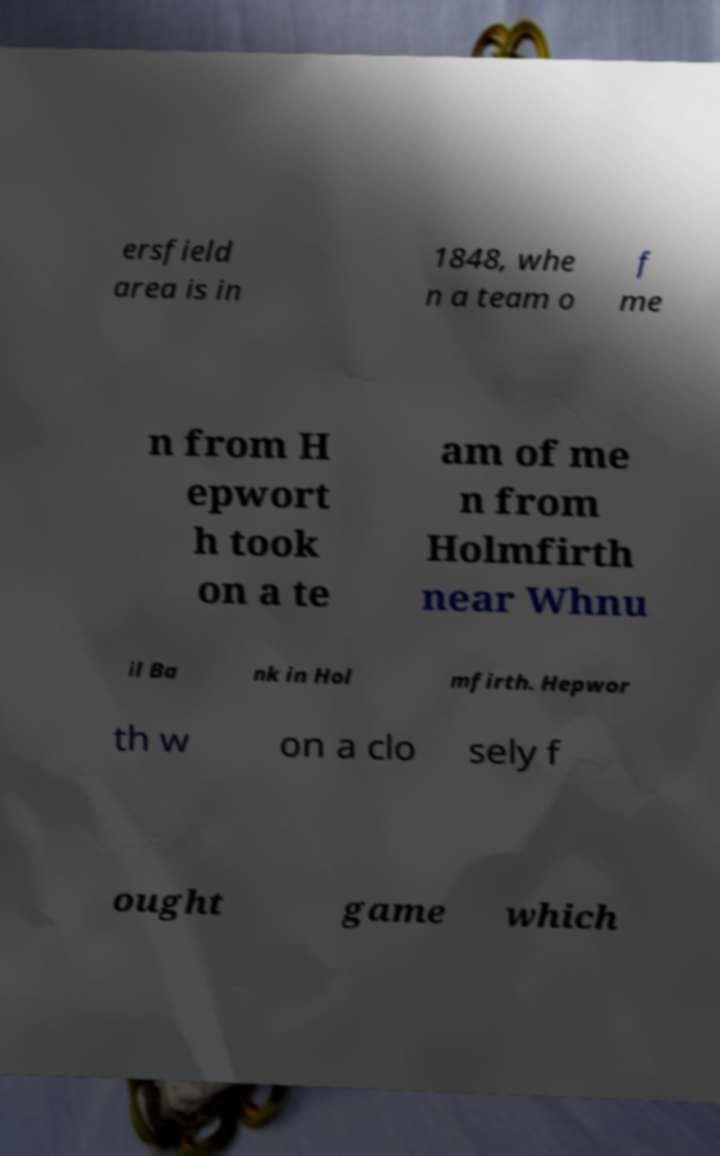What messages or text are displayed in this image? I need them in a readable, typed format. ersfield area is in 1848, whe n a team o f me n from H epwort h took on a te am of me n from Holmfirth near Whnu il Ba nk in Hol mfirth. Hepwor th w on a clo sely f ought game which 